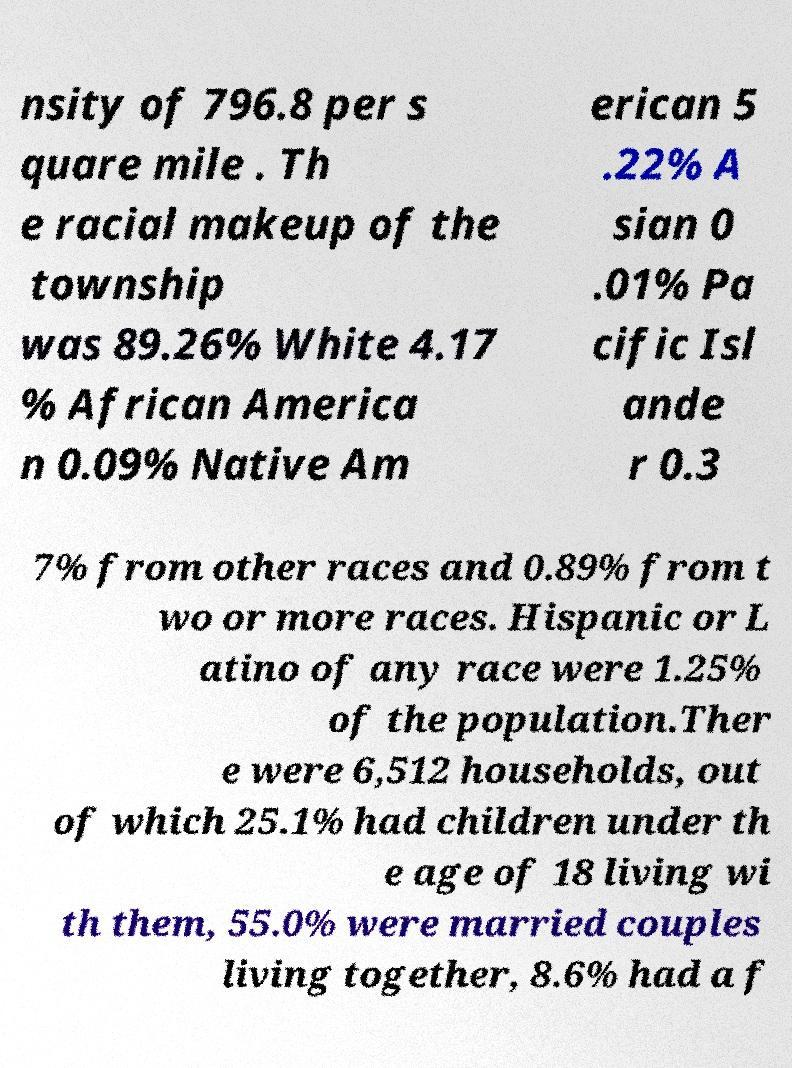Please identify and transcribe the text found in this image. nsity of 796.8 per s quare mile . Th e racial makeup of the township was 89.26% White 4.17 % African America n 0.09% Native Am erican 5 .22% A sian 0 .01% Pa cific Isl ande r 0.3 7% from other races and 0.89% from t wo or more races. Hispanic or L atino of any race were 1.25% of the population.Ther e were 6,512 households, out of which 25.1% had children under th e age of 18 living wi th them, 55.0% were married couples living together, 8.6% had a f 